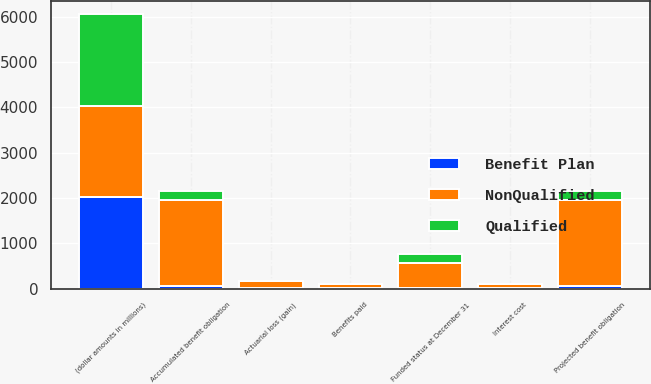<chart> <loc_0><loc_0><loc_500><loc_500><stacked_bar_chart><ecel><fcel>(dollar amounts in millions)<fcel>Projected benefit obligation<fcel>Interest cost<fcel>Actuarial loss (gain)<fcel>Benefits paid<fcel>Accumulated benefit obligation<fcel>Funded status at December 31<nl><fcel>NonQualified<fcel>2016<fcel>1902<fcel>87<fcel>161<fcel>93<fcel>1894<fcel>551<nl><fcel>Qualified<fcel>2016<fcel>201<fcel>10<fcel>11<fcel>11<fcel>198<fcel>201<nl><fcel>Benefit Plan<fcel>2016<fcel>55<fcel>3<fcel>2<fcel>5<fcel>55<fcel>7<nl></chart> 